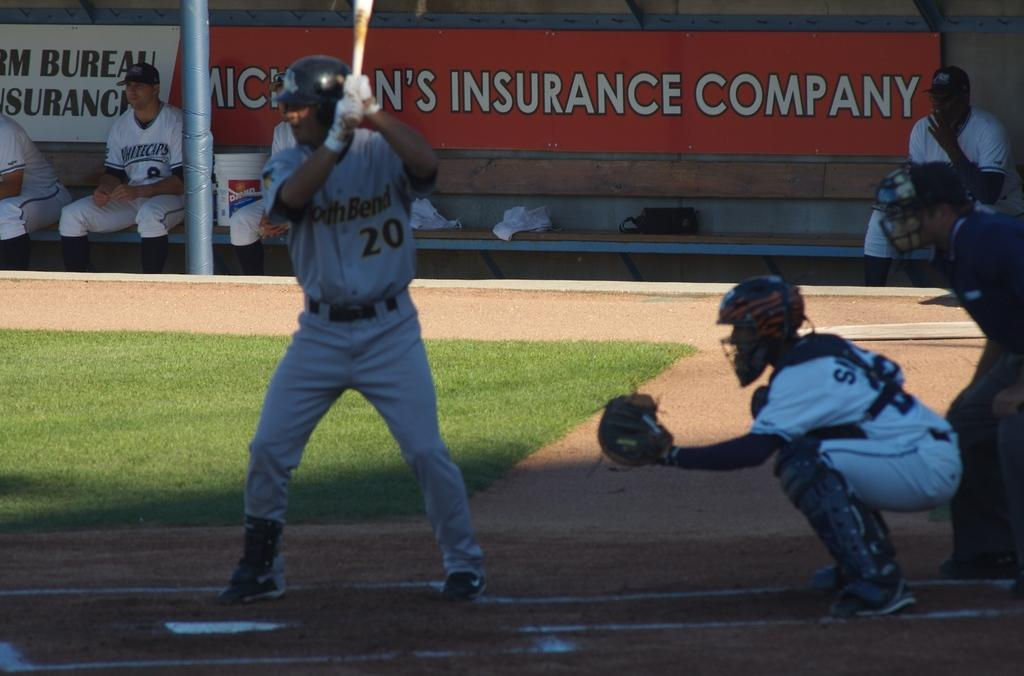<image>
Provide a brief description of the given image. Number 20 is at the plate and ready to bat next. 